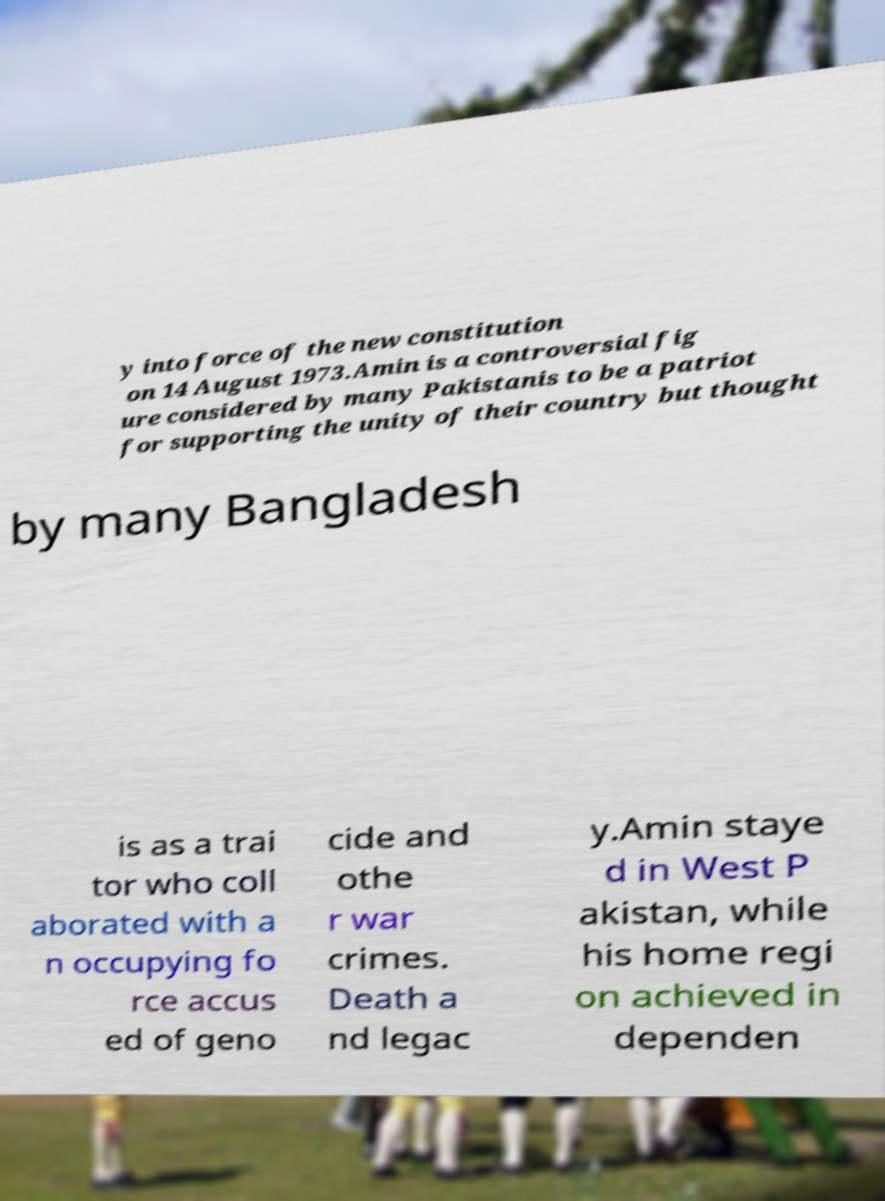Could you extract and type out the text from this image? y into force of the new constitution on 14 August 1973.Amin is a controversial fig ure considered by many Pakistanis to be a patriot for supporting the unity of their country but thought by many Bangladesh is as a trai tor who coll aborated with a n occupying fo rce accus ed of geno cide and othe r war crimes. Death a nd legac y.Amin staye d in West P akistan, while his home regi on achieved in dependen 